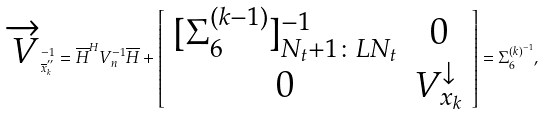<formula> <loc_0><loc_0><loc_500><loc_500>\overrightarrow { V } _ { \overline { x } _ { k } ^ { ^ { \prime \prime } } } ^ { - 1 } = \overline { H } ^ { H } V _ { n } ^ { - 1 } \overline { H } + \left [ \begin{array} { c c } [ \Sigma _ { 6 } ^ { ( k - 1 ) } ] _ { N _ { t } + 1 \colon L N _ { t } } ^ { - 1 } & 0 \\ 0 & V _ { x _ { k } } ^ { \downarrow } \end{array} \right ] = \Sigma _ { 6 } ^ { ( k ) ^ { - 1 } } ,</formula> 